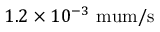Convert formula to latex. <formula><loc_0><loc_0><loc_500><loc_500>1 . 2 \times 1 0 ^ { - 3 } \ m u m / s</formula> 